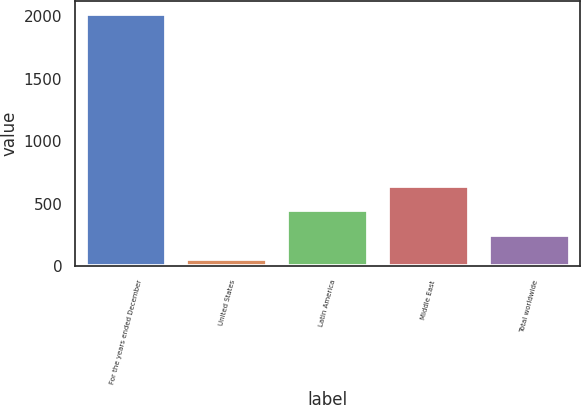Convert chart to OTSL. <chart><loc_0><loc_0><loc_500><loc_500><bar_chart><fcel>For the years ended December<fcel>United States<fcel>Latin America<fcel>Middle East<fcel>Total worldwide<nl><fcel>2018<fcel>56.3<fcel>448.64<fcel>644.81<fcel>252.47<nl></chart> 